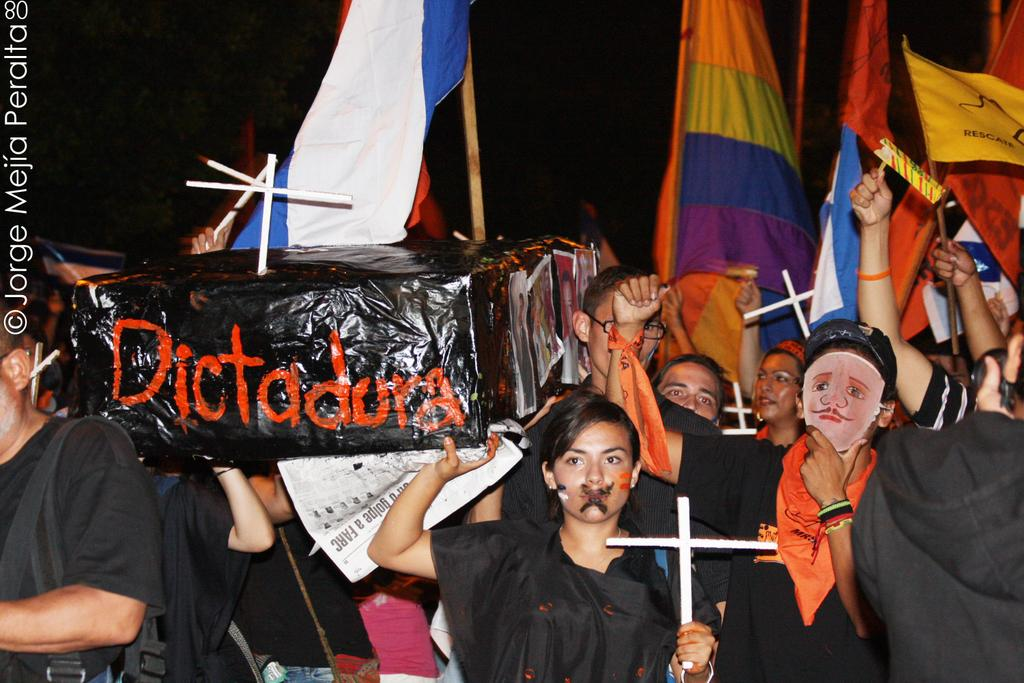What are the people in the image doing? There is a group of people standing in the image. What objects are some of the people holding? Some people are holding holy cross symbols, flags, and a box. What can be observed about the background of the image? The background appears to be dark. Is there any additional information about the image itself? Yes, there is a watermark on the image. What type of thumb is being used to plot a joke in the image? There is no thumb, plot, or joke present in the image. 